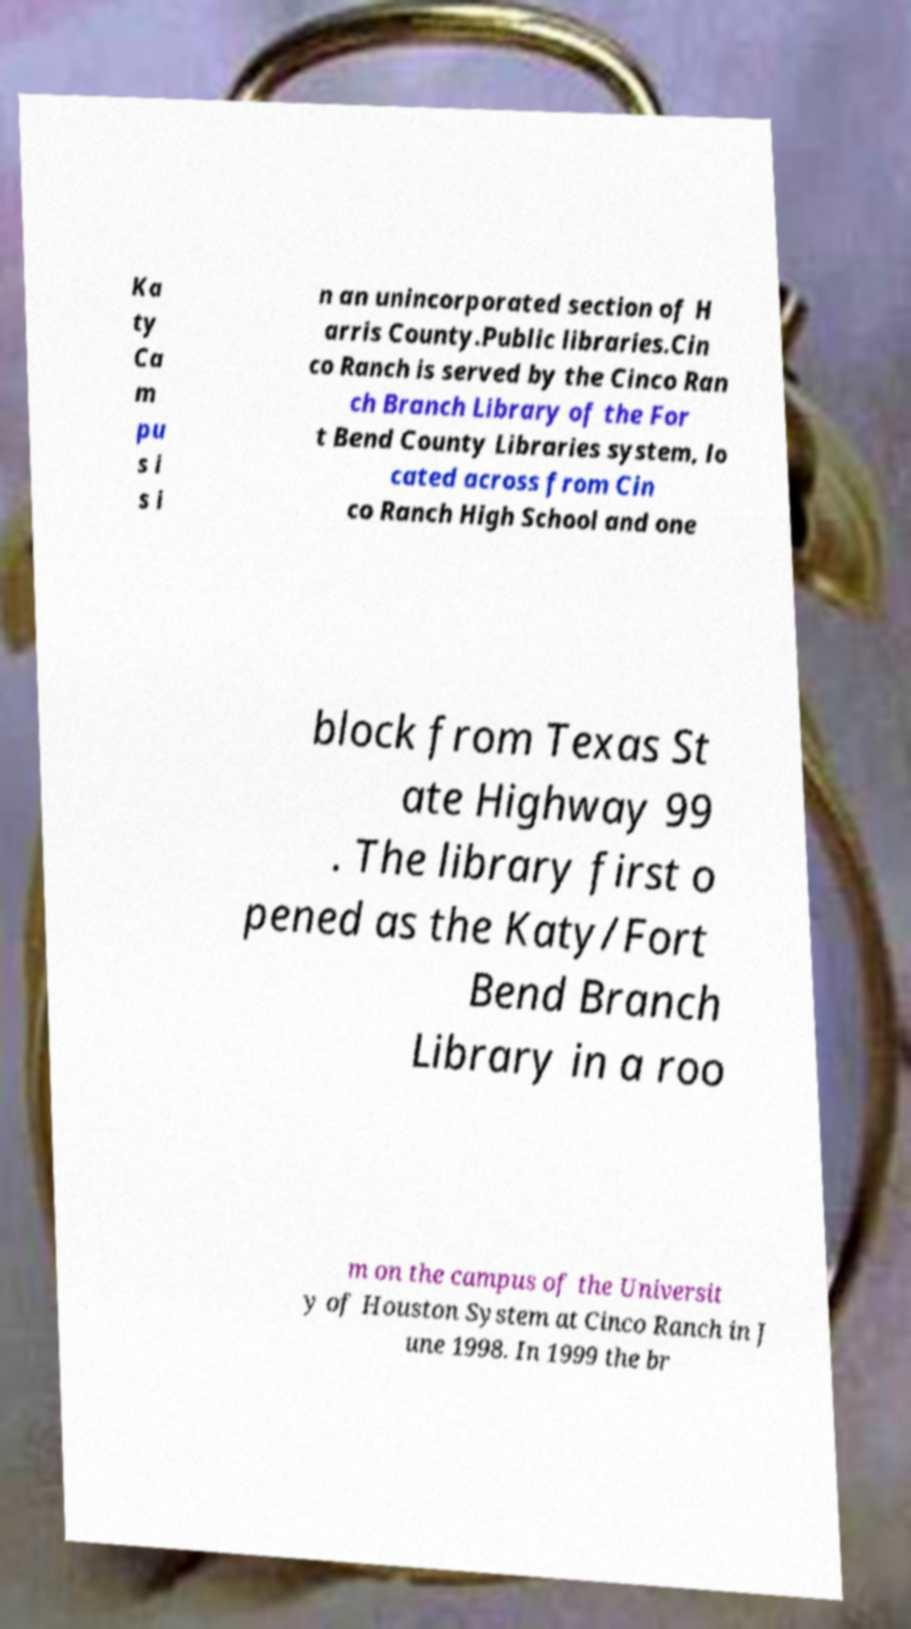Can you accurately transcribe the text from the provided image for me? Ka ty Ca m pu s i s i n an unincorporated section of H arris County.Public libraries.Cin co Ranch is served by the Cinco Ran ch Branch Library of the For t Bend County Libraries system, lo cated across from Cin co Ranch High School and one block from Texas St ate Highway 99 . The library first o pened as the Katy/Fort Bend Branch Library in a roo m on the campus of the Universit y of Houston System at Cinco Ranch in J une 1998. In 1999 the br 